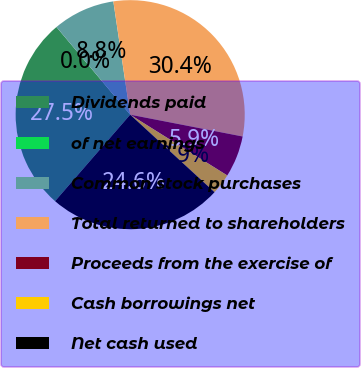Convert chart to OTSL. <chart><loc_0><loc_0><loc_500><loc_500><pie_chart><fcel>Dividends paid<fcel>of net earnings<fcel>Common stock purchases<fcel>Total returned to shareholders<fcel>Proceeds from the exercise of<fcel>Cash borrowings net<fcel>Net cash used<nl><fcel>27.48%<fcel>0.0%<fcel>8.78%<fcel>30.4%<fcel>5.85%<fcel>2.93%<fcel>24.55%<nl></chart> 